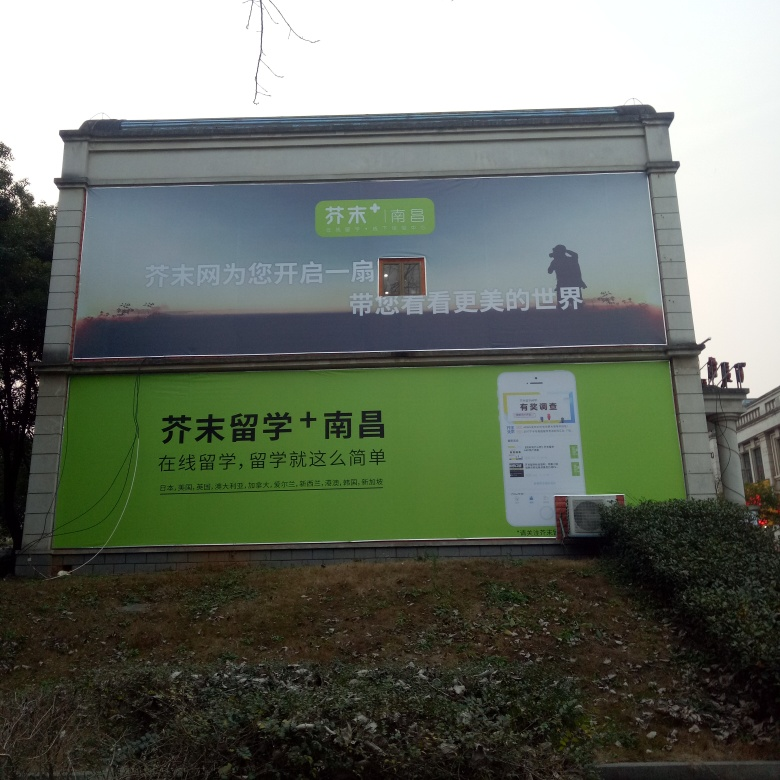Can you give me an idea of the environment where this billboard is located? The billboard is positioned outdoors, likely along a road given the visible curb on the lower right. The absence of surrounding buildings and presence of shrubbery suggest a less urban, more open area. The sky is overcast, indicating it might be a cloudy day. Does the billboard seem to be well-maintained? There are signs of wear, such as dirt smudges on the edges and corners, and a slight fade in the billboard's colors, indicating it may not be regularly cleaned or recently updated. The advertisement itself remains legible, though, so it continues to serve its purpose. 